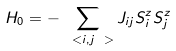Convert formula to latex. <formula><loc_0><loc_0><loc_500><loc_500>H _ { 0 } = - \sum _ { \ < i , j \ > } J _ { i j } S ^ { z } _ { i } S ^ { z } _ { j }</formula> 